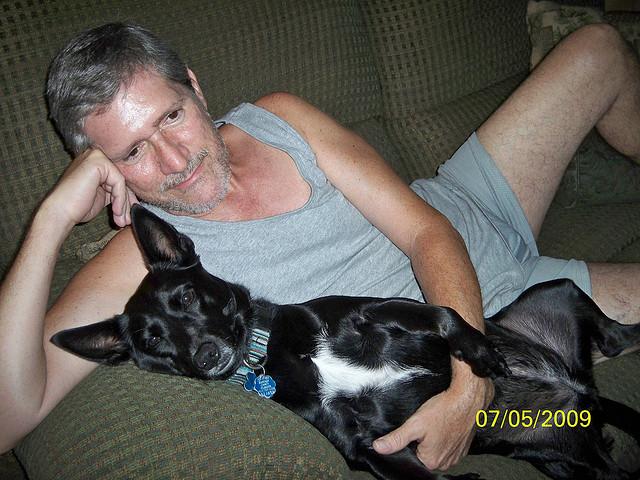Is this type of hair called by the same name as two popular condiments?
Give a very brief answer. No. What breed is the dog?
Keep it brief. Black lab. What color is the dog's collar?
Write a very short answer. Black. Is the dog wearing a rabies tag?
Short answer required. Yes. What year was this picture taken?
Keep it brief. 2009. 